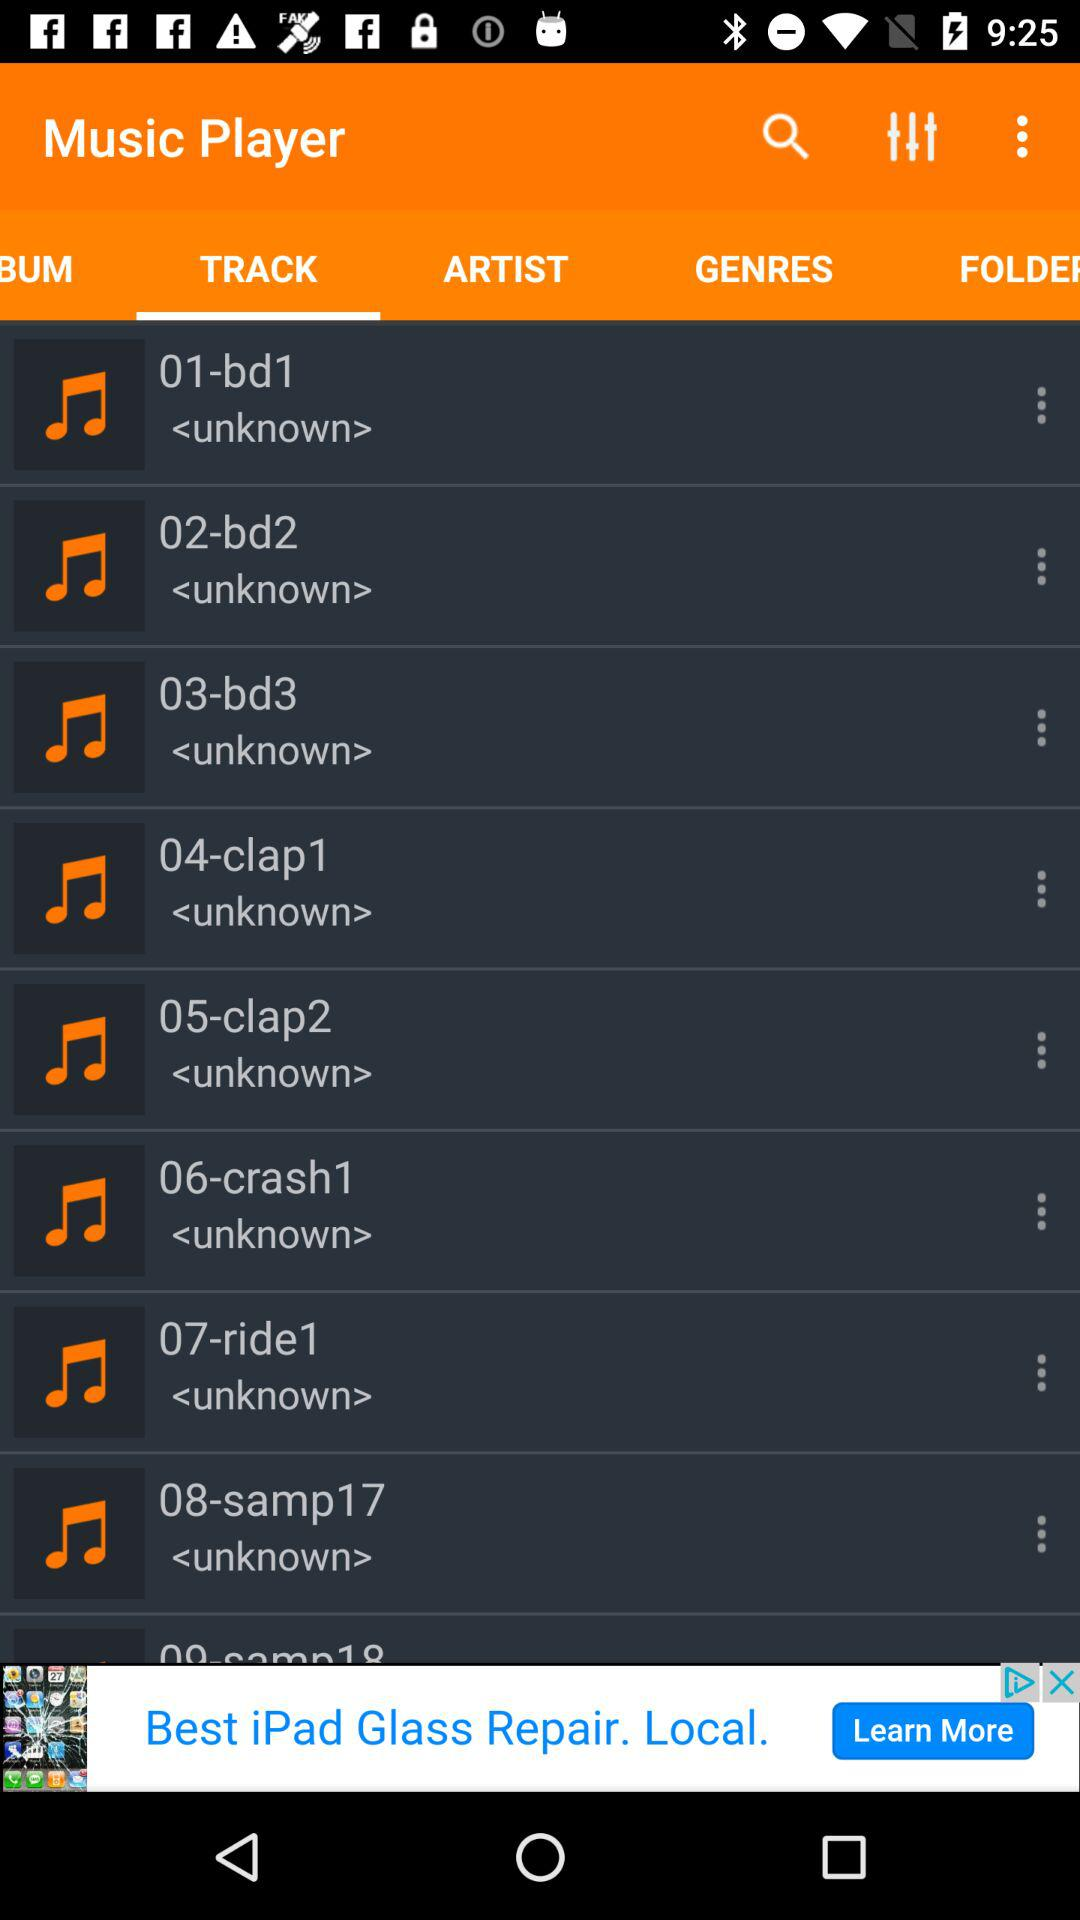What is the selected tab? The selected tab is "TRACK". 